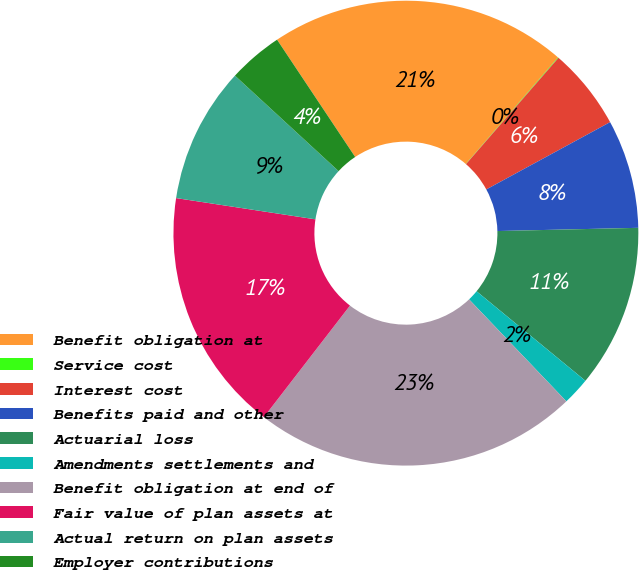Convert chart to OTSL. <chart><loc_0><loc_0><loc_500><loc_500><pie_chart><fcel>Benefit obligation at<fcel>Service cost<fcel>Interest cost<fcel>Benefits paid and other<fcel>Actuarial loss<fcel>Amendments settlements and<fcel>Benefit obligation at end of<fcel>Fair value of plan assets at<fcel>Actual return on plan assets<fcel>Employer contributions<nl><fcel>20.71%<fcel>0.04%<fcel>5.68%<fcel>7.56%<fcel>11.32%<fcel>1.92%<fcel>22.59%<fcel>16.95%<fcel>9.44%<fcel>3.8%<nl></chart> 